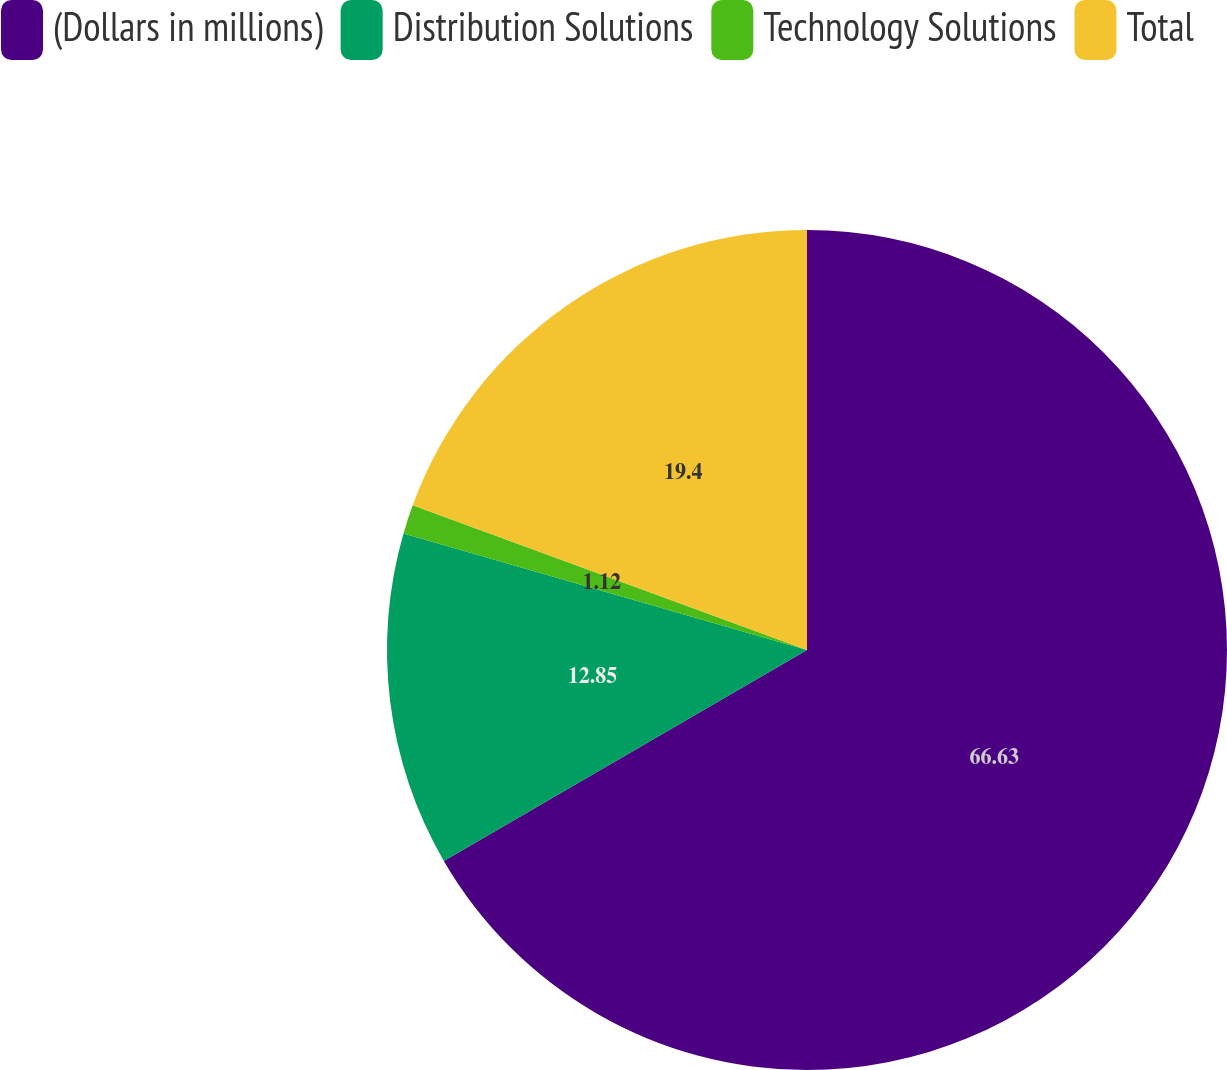<chart> <loc_0><loc_0><loc_500><loc_500><pie_chart><fcel>(Dollars in millions)<fcel>Distribution Solutions<fcel>Technology Solutions<fcel>Total<nl><fcel>66.62%<fcel>12.85%<fcel>1.12%<fcel>19.4%<nl></chart> 